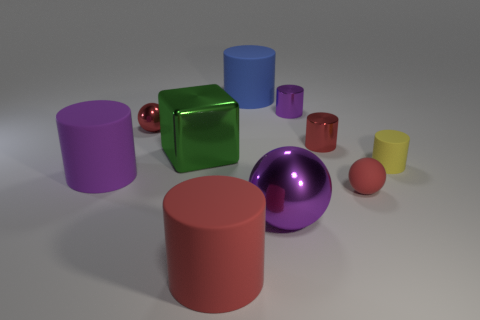Subtract all red spheres. How many spheres are left? 1 Subtract all blue cylinders. How many cylinders are left? 5 Subtract all cylinders. How many objects are left? 4 Subtract all blue balls. Subtract all gray cubes. How many balls are left? 3 Subtract all brown cylinders. How many yellow spheres are left? 0 Subtract all tiny gray objects. Subtract all green metal cubes. How many objects are left? 9 Add 9 tiny matte cylinders. How many tiny matte cylinders are left? 10 Add 9 small purple blocks. How many small purple blocks exist? 9 Subtract 0 purple blocks. How many objects are left? 10 